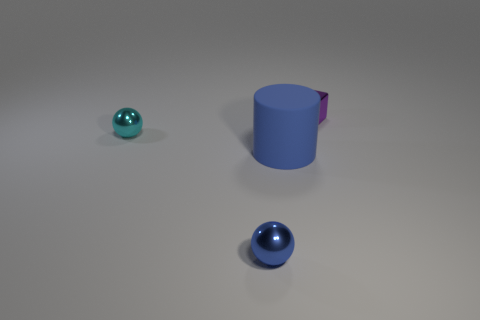Are there any large blue shiny things that have the same shape as the purple metal thing?
Offer a terse response. No. The shiny sphere that is the same size as the cyan thing is what color?
Keep it short and to the point. Blue. Are there fewer small purple shiny blocks that are in front of the blue shiny ball than small metallic objects that are behind the rubber cylinder?
Your response must be concise. Yes. There is a object behind the cyan sphere; does it have the same size as the blue shiny ball?
Keep it short and to the point. Yes. What shape is the shiny object that is on the right side of the tiny blue object?
Give a very brief answer. Cube. Is the number of red objects greater than the number of small cyan shiny objects?
Keep it short and to the point. No. There is a shiny thing that is in front of the cyan ball; does it have the same color as the big cylinder?
Provide a short and direct response. Yes. What number of objects are either tiny metal things left of the purple block or things on the left side of the tiny purple shiny block?
Ensure brevity in your answer.  3. What number of small objects are on the right side of the cyan sphere and behind the blue shiny thing?
Keep it short and to the point. 1. Is the big thing made of the same material as the block?
Give a very brief answer. No. 